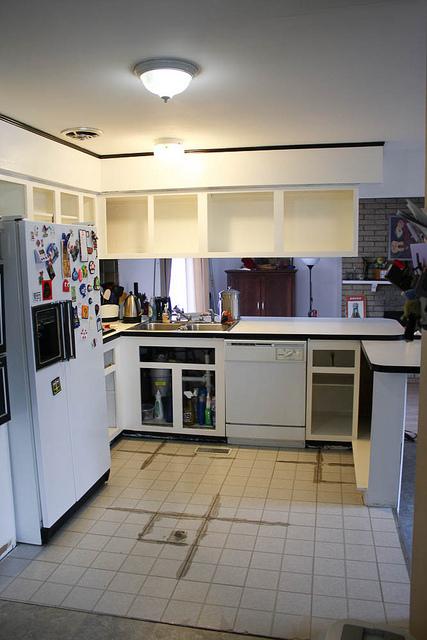What is the flooring in the kitchen?
Keep it brief. Tile. How many cabinets in the background are empty?
Short answer required. 8. What is on the refrigerator?
Keep it brief. Magnets. 